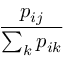Convert formula to latex. <formula><loc_0><loc_0><loc_500><loc_500>\frac { p _ { i j } } { \sum _ { k } p _ { i k } }</formula> 